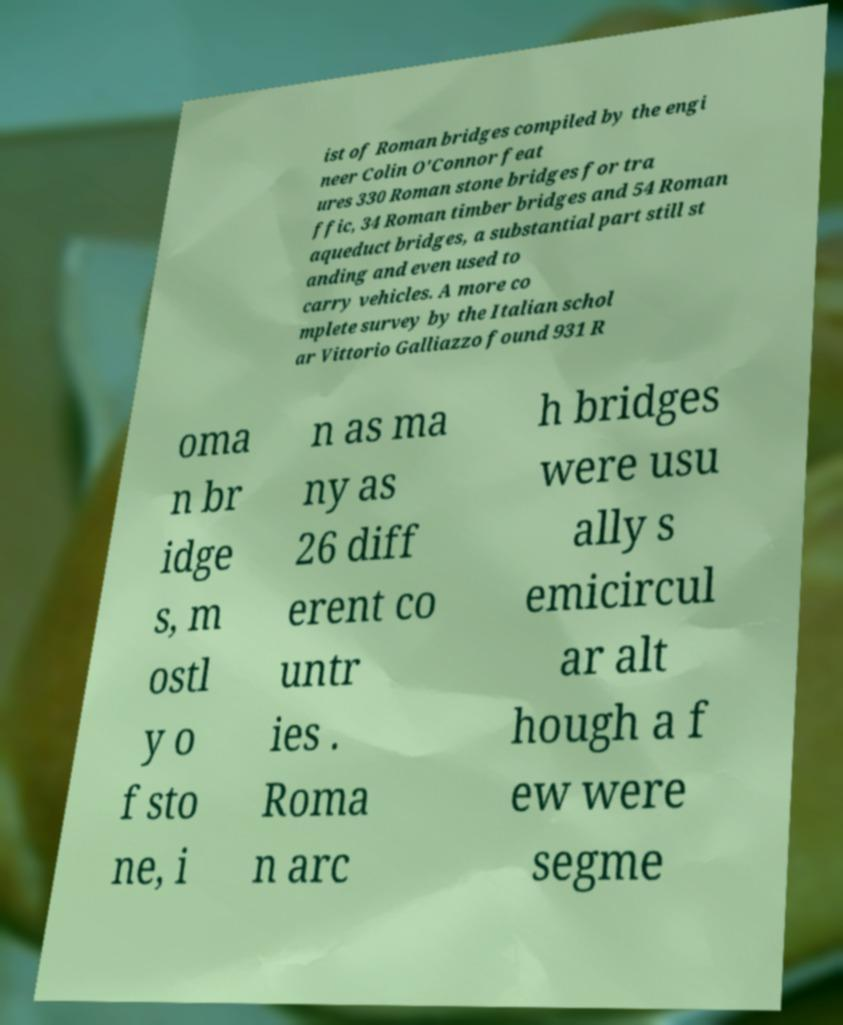There's text embedded in this image that I need extracted. Can you transcribe it verbatim? ist of Roman bridges compiled by the engi neer Colin O'Connor feat ures 330 Roman stone bridges for tra ffic, 34 Roman timber bridges and 54 Roman aqueduct bridges, a substantial part still st anding and even used to carry vehicles. A more co mplete survey by the Italian schol ar Vittorio Galliazzo found 931 R oma n br idge s, m ostl y o f sto ne, i n as ma ny as 26 diff erent co untr ies . Roma n arc h bridges were usu ally s emicircul ar alt hough a f ew were segme 